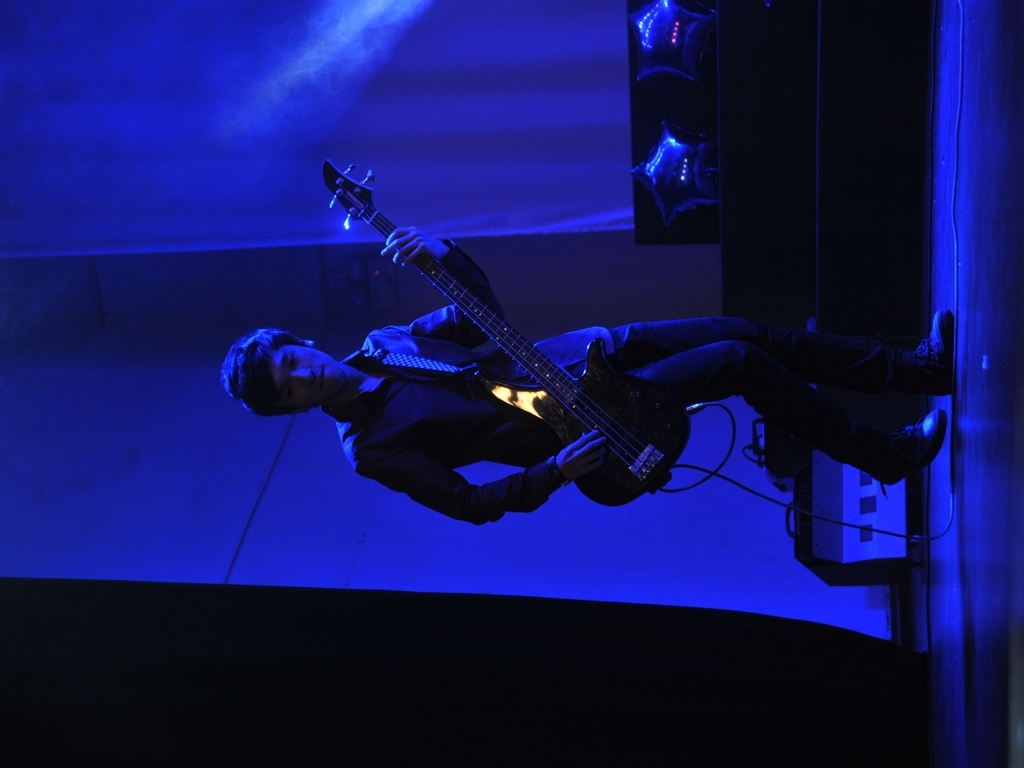Can you describe the atmosphere of the venue? The venue exudes a kind of intimate vibe, emphasized by the enveloping darkness and the focused beam of blue light on the bassist. The presence of balloons suggests a festive occasion, while the unadorned backdrop and absence of a visible audience indicate a possibly small, exclusive event. It feels like a setting where a deep connection between the performer and the music can be forged. 